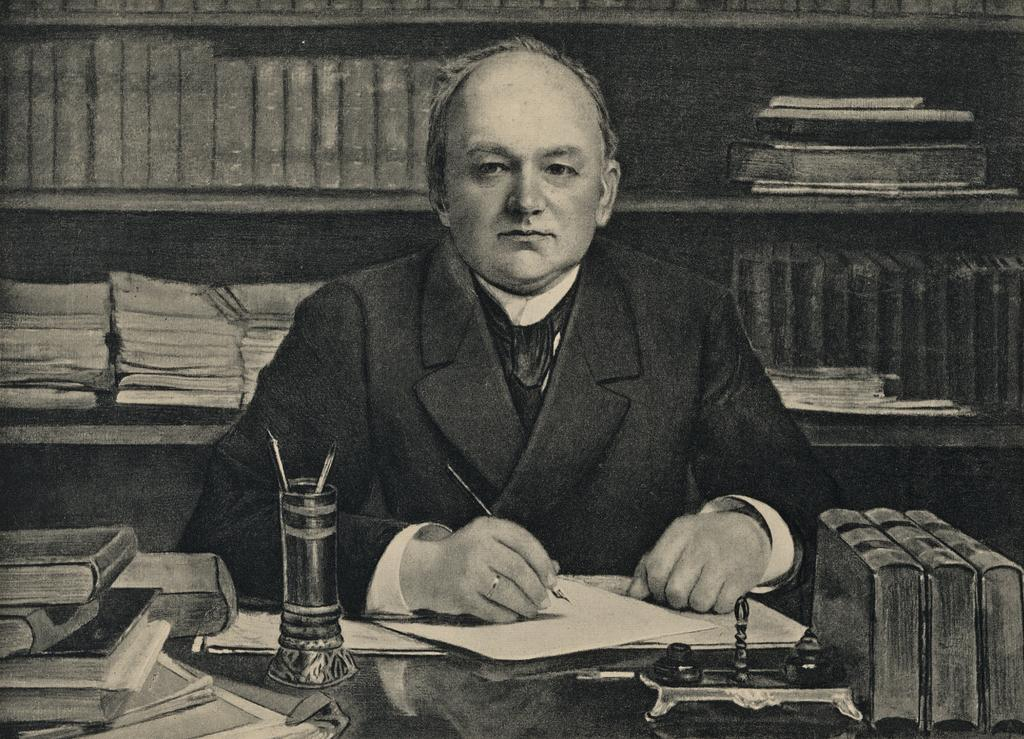What is the person in the image doing? The person is sitting in the image. What is the person holding in the image? The person is holding a pen. What items are in front of the person? There are books and papers in front of the person. What can be seen on the table in the image? There are objects on the table. What is visible in the background of the image? There is a book rack in the background of the image. What type of spoon is being used by the person in the image? There is no spoon present in the image. How many tickets does the person have in the image? There are no tickets present in the image. 